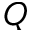Convert formula to latex. <formula><loc_0><loc_0><loc_500><loc_500>Q</formula> 